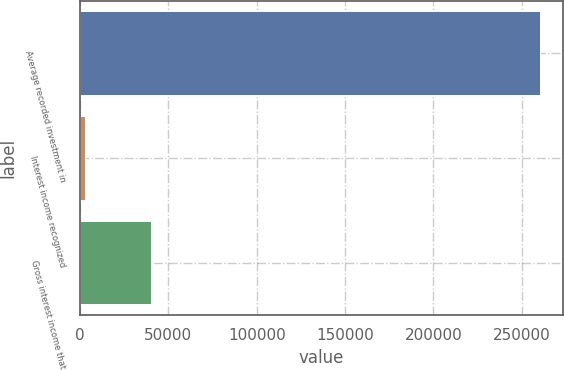<chart> <loc_0><loc_0><loc_500><loc_500><bar_chart><fcel>Average recorded investment in<fcel>Interest income recognized<fcel>Gross interest income that<nl><fcel>260251<fcel>2946<fcel>39917<nl></chart> 